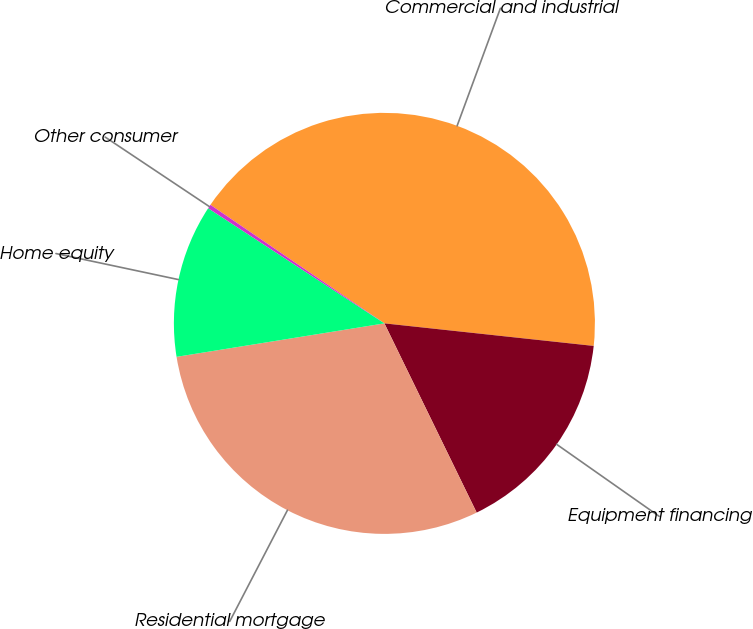<chart> <loc_0><loc_0><loc_500><loc_500><pie_chart><fcel>Commercial and industrial<fcel>Equipment financing<fcel>Residential mortgage<fcel>Home equity<fcel>Other consumer<nl><fcel>42.19%<fcel>16.07%<fcel>29.68%<fcel>11.75%<fcel>0.31%<nl></chart> 